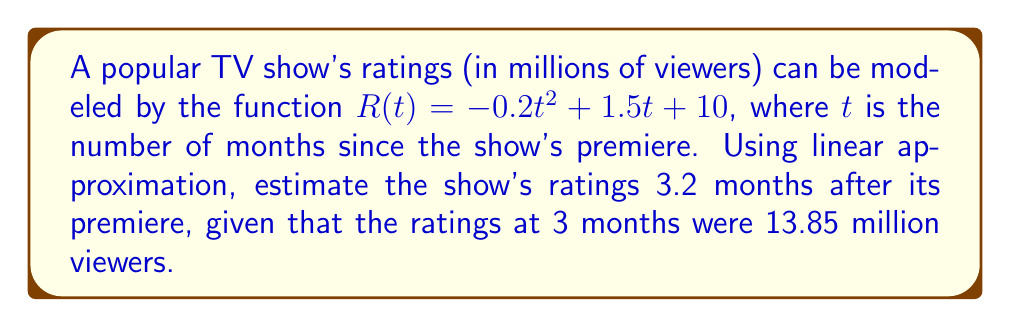Could you help me with this problem? 1. We need to use the tangent line at $t = 3$ to estimate the ratings at $t = 3.2$.

2. Find $R(3)$:
   $R(3) = -0.2(3)^2 + 1.5(3) + 10 = -1.8 + 4.5 + 10 = 13.85$ million viewers

3. Calculate $R'(t)$:
   $R'(t) = -0.4t + 1.5$

4. Find $R'(3)$:
   $R'(3) = -0.4(3) + 1.5 = -1.2 + 1.5 = 0.3$

5. The equation of the tangent line at $t = 3$ is:
   $y - R(3) = R'(3)(t - 3)$
   $y - 13.85 = 0.3(t - 3)$

6. Use linear approximation to estimate $R(3.2)$:
   $R(3.2) \approx 13.85 + 0.3(3.2 - 3)$
   $R(3.2) \approx 13.85 + 0.3(0.2)$
   $R(3.2) \approx 13.85 + 0.06$
   $R(3.2) \approx 13.91$

Therefore, the estimated ratings 3.2 months after the premiere are approximately 13.91 million viewers.
Answer: 13.91 million viewers 